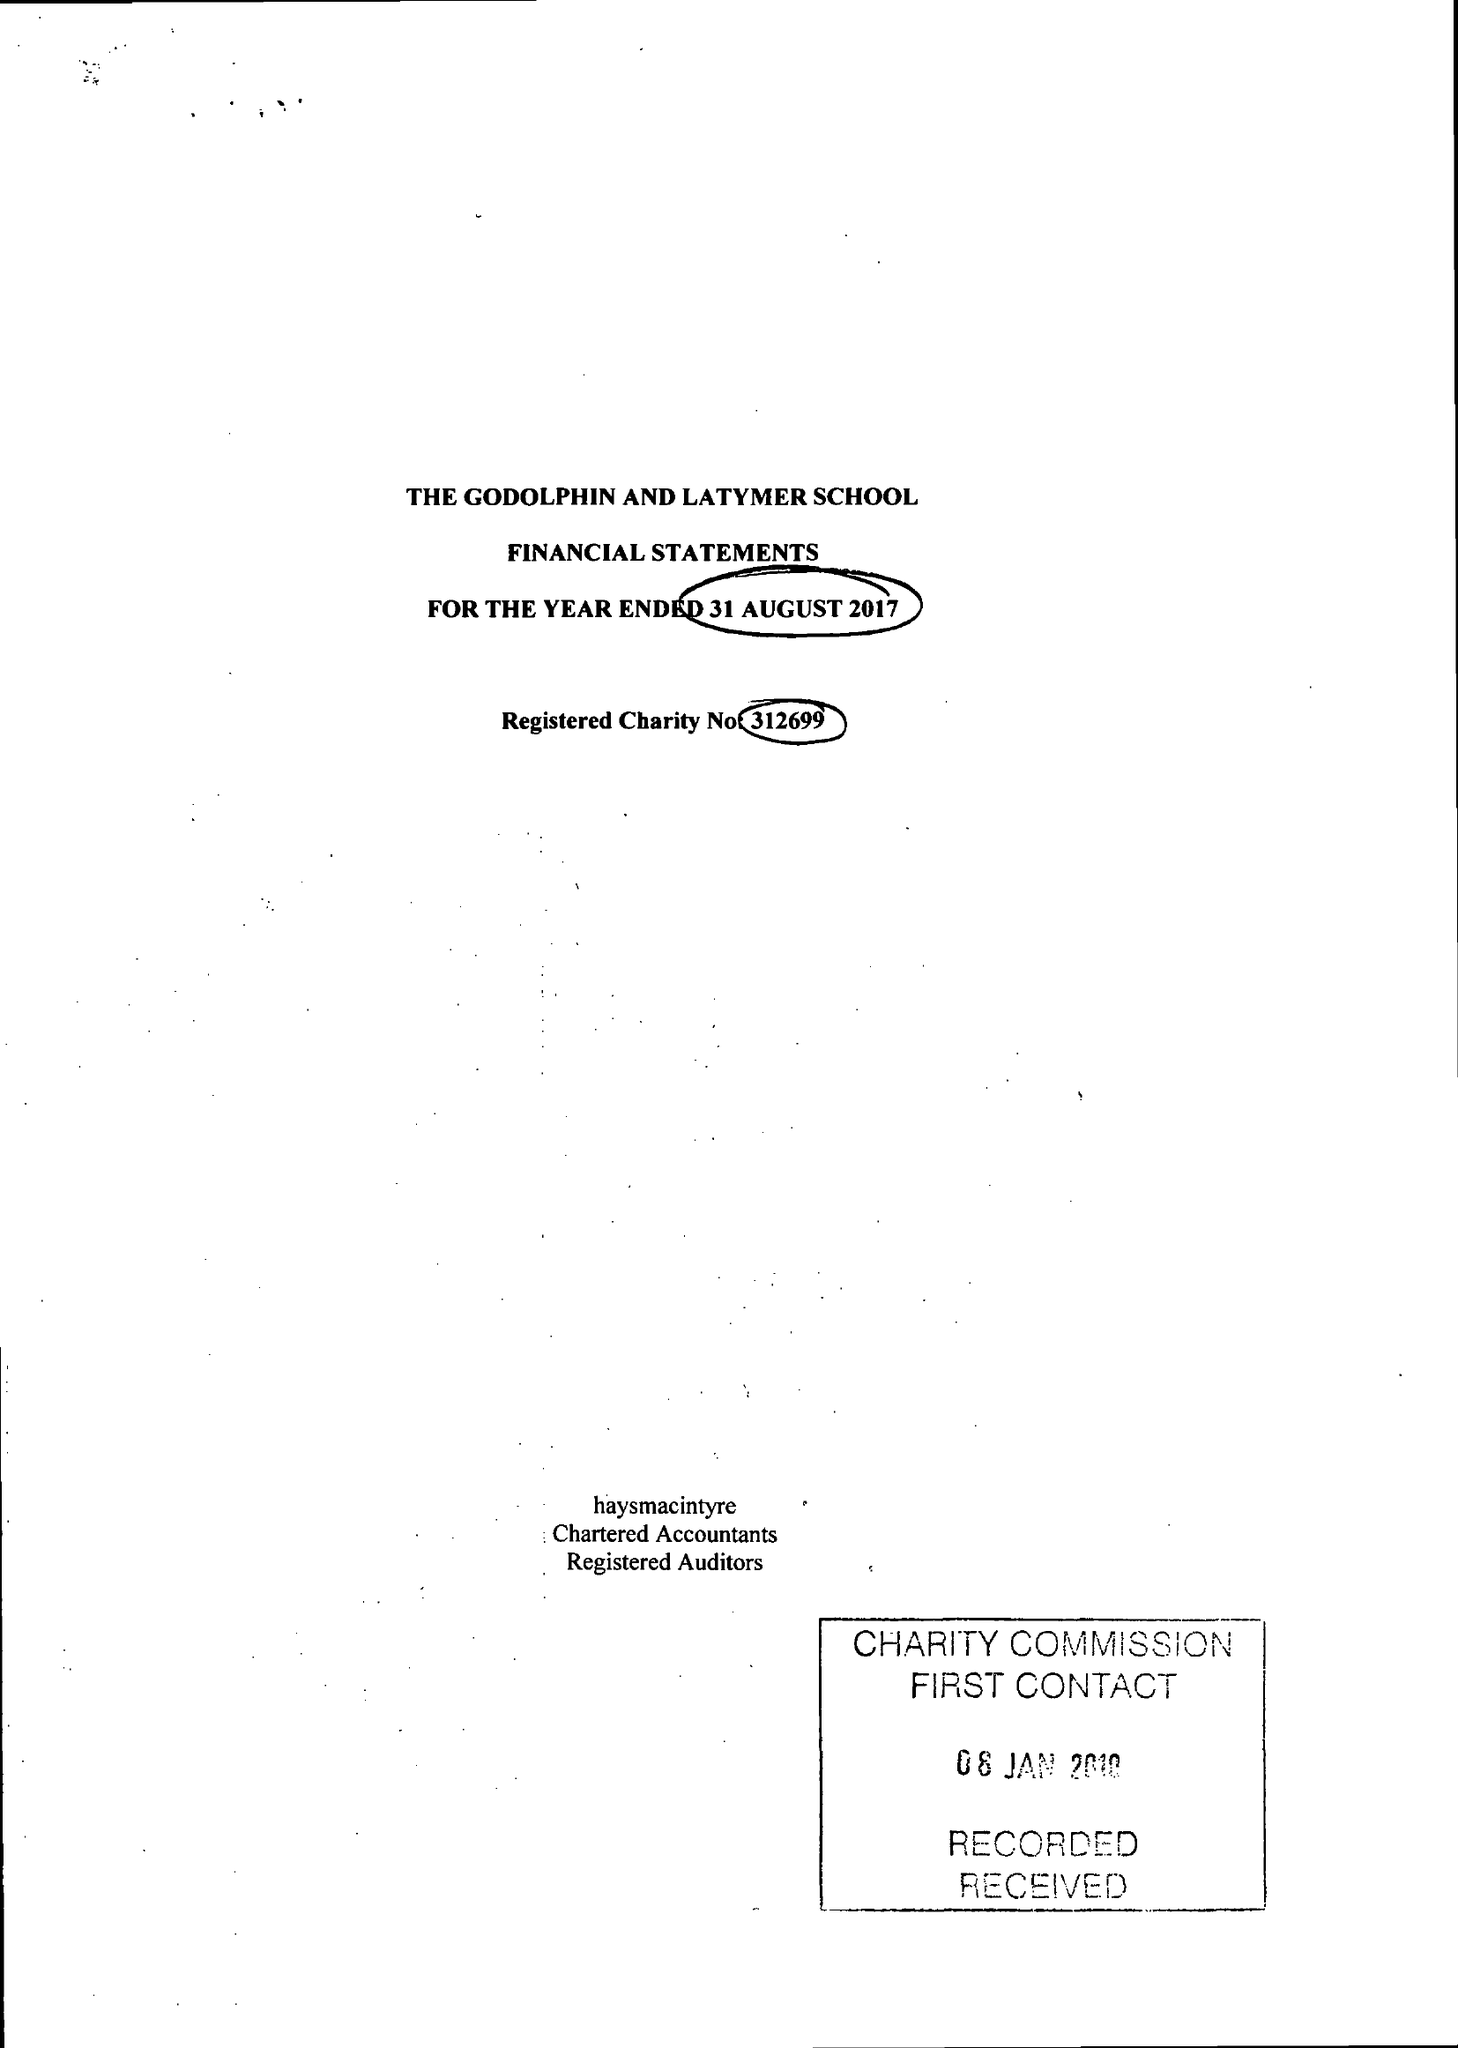What is the value for the address__postcode?
Answer the question using a single word or phrase. W6 0PG 